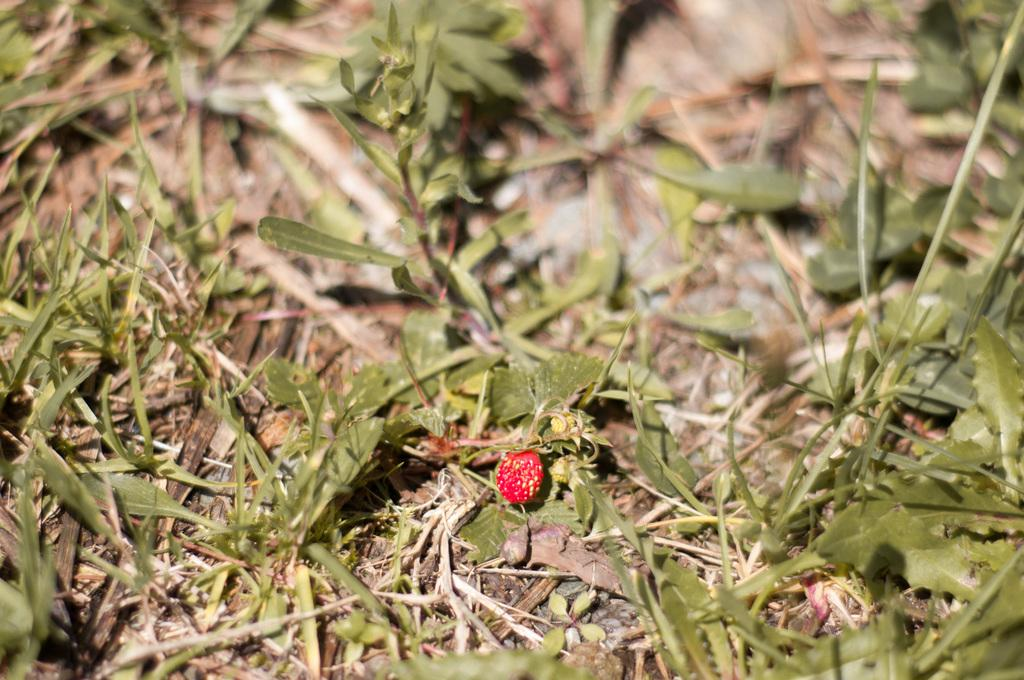What type of fruit is visible in the image? There is a red color fruit in the image. What other living organisms can be seen in the image? There are plants in the image. What type of ground surface is visible in the image? There is grass on the ground in the image. How would you describe the background of the image? The background of the image is blurred. Is there a girl playing with a ball in the park in the image? There is no girl or park present in the image; it features a red color fruit, plants, grass, and a blurred background. 